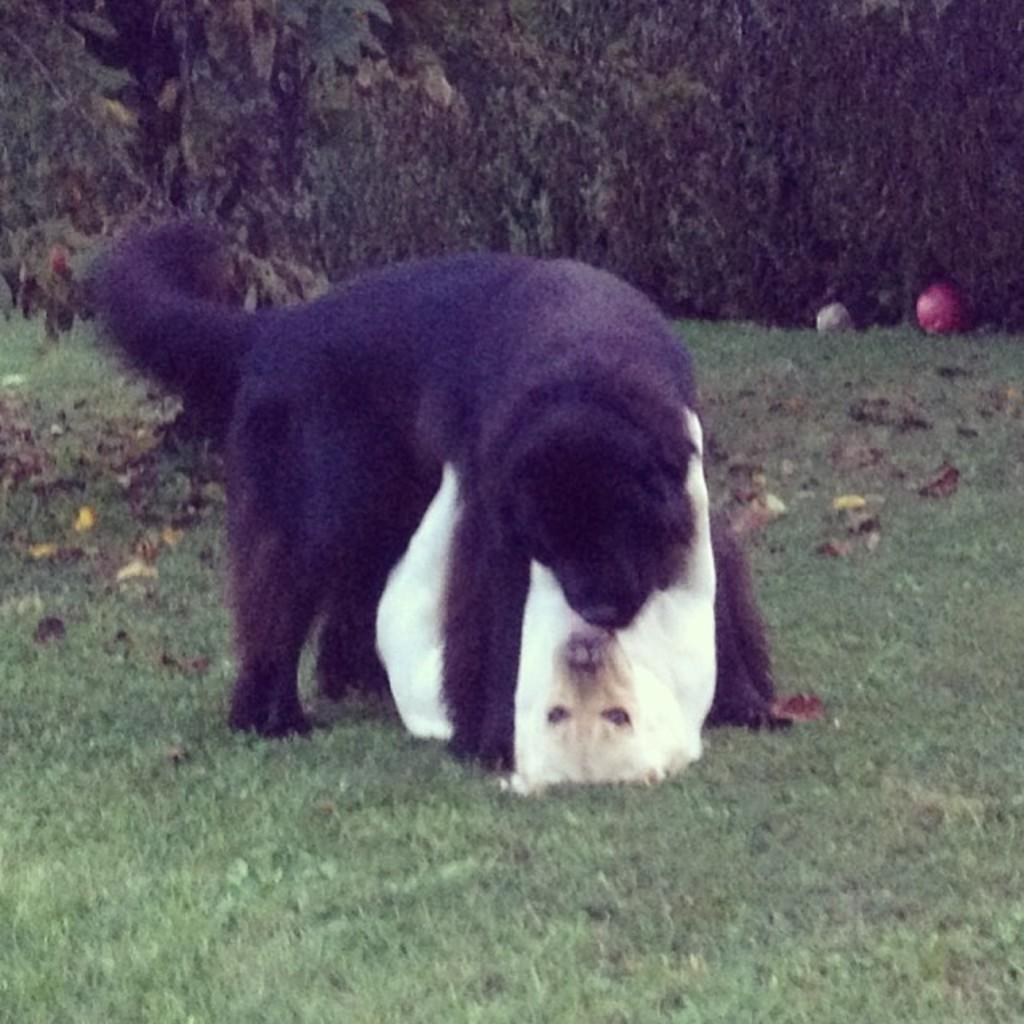How many dogs are present in the image? There are two dogs in the image. What is the surface the dogs are standing on? The dogs are on the grass ground. How are the dogs positioned in relation to each other? The dogs are positioned one above the other. What can be seen in the background of the image? There are trees visible in the background of the image. What type of insect is sitting on the dog's head in the image? There is no insect present on the dogs' heads in the image. Who is the friend of the dog in the image? The image does not show the dogs interacting with a friend; it only shows the two dogs positioned one above the other. 